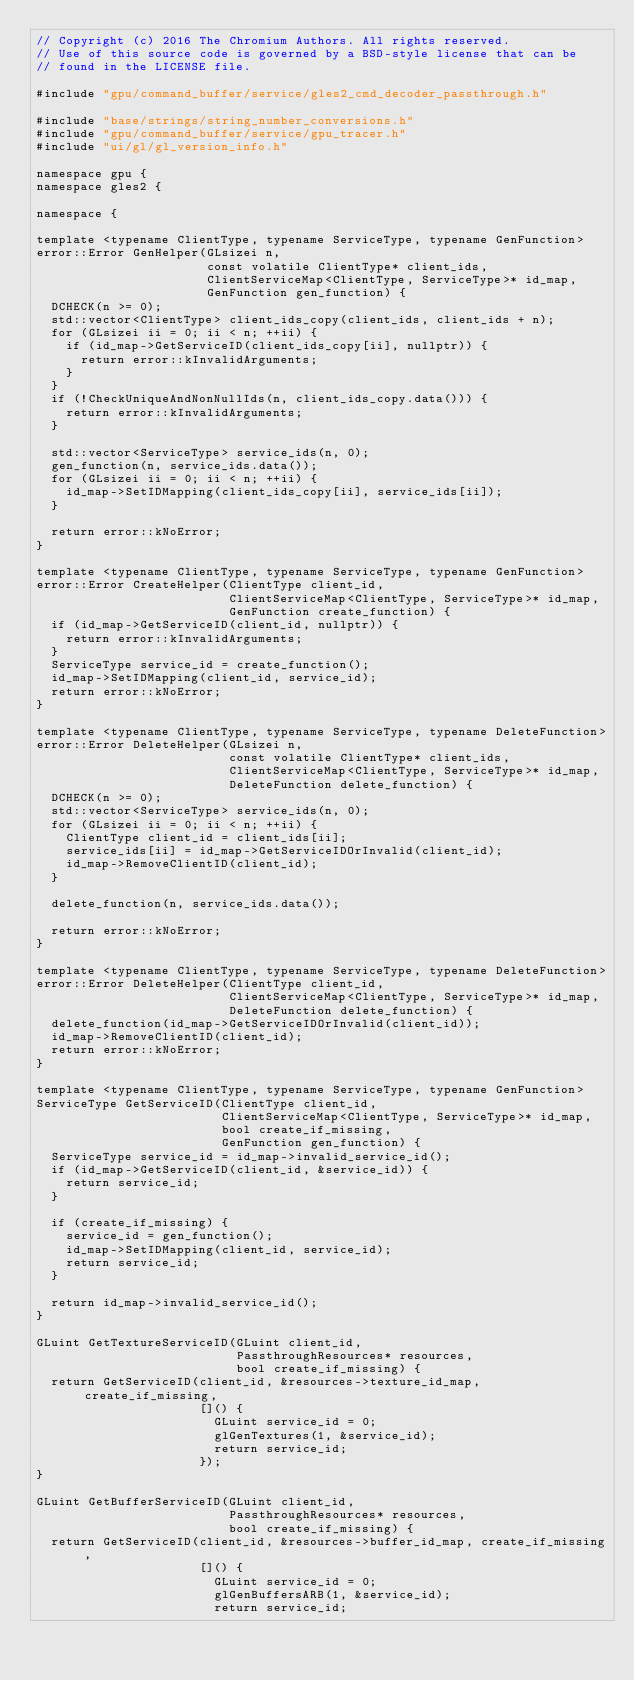<code> <loc_0><loc_0><loc_500><loc_500><_C++_>// Copyright (c) 2016 The Chromium Authors. All rights reserved.
// Use of this source code is governed by a BSD-style license that can be
// found in the LICENSE file.

#include "gpu/command_buffer/service/gles2_cmd_decoder_passthrough.h"

#include "base/strings/string_number_conversions.h"
#include "gpu/command_buffer/service/gpu_tracer.h"
#include "ui/gl/gl_version_info.h"

namespace gpu {
namespace gles2 {

namespace {

template <typename ClientType, typename ServiceType, typename GenFunction>
error::Error GenHelper(GLsizei n,
                       const volatile ClientType* client_ids,
                       ClientServiceMap<ClientType, ServiceType>* id_map,
                       GenFunction gen_function) {
  DCHECK(n >= 0);
  std::vector<ClientType> client_ids_copy(client_ids, client_ids + n);
  for (GLsizei ii = 0; ii < n; ++ii) {
    if (id_map->GetServiceID(client_ids_copy[ii], nullptr)) {
      return error::kInvalidArguments;
    }
  }
  if (!CheckUniqueAndNonNullIds(n, client_ids_copy.data())) {
    return error::kInvalidArguments;
  }

  std::vector<ServiceType> service_ids(n, 0);
  gen_function(n, service_ids.data());
  for (GLsizei ii = 0; ii < n; ++ii) {
    id_map->SetIDMapping(client_ids_copy[ii], service_ids[ii]);
  }

  return error::kNoError;
}

template <typename ClientType, typename ServiceType, typename GenFunction>
error::Error CreateHelper(ClientType client_id,
                          ClientServiceMap<ClientType, ServiceType>* id_map,
                          GenFunction create_function) {
  if (id_map->GetServiceID(client_id, nullptr)) {
    return error::kInvalidArguments;
  }
  ServiceType service_id = create_function();
  id_map->SetIDMapping(client_id, service_id);
  return error::kNoError;
}

template <typename ClientType, typename ServiceType, typename DeleteFunction>
error::Error DeleteHelper(GLsizei n,
                          const volatile ClientType* client_ids,
                          ClientServiceMap<ClientType, ServiceType>* id_map,
                          DeleteFunction delete_function) {
  DCHECK(n >= 0);
  std::vector<ServiceType> service_ids(n, 0);
  for (GLsizei ii = 0; ii < n; ++ii) {
    ClientType client_id = client_ids[ii];
    service_ids[ii] = id_map->GetServiceIDOrInvalid(client_id);
    id_map->RemoveClientID(client_id);
  }

  delete_function(n, service_ids.data());

  return error::kNoError;
}

template <typename ClientType, typename ServiceType, typename DeleteFunction>
error::Error DeleteHelper(ClientType client_id,
                          ClientServiceMap<ClientType, ServiceType>* id_map,
                          DeleteFunction delete_function) {
  delete_function(id_map->GetServiceIDOrInvalid(client_id));
  id_map->RemoveClientID(client_id);
  return error::kNoError;
}

template <typename ClientType, typename ServiceType, typename GenFunction>
ServiceType GetServiceID(ClientType client_id,
                         ClientServiceMap<ClientType, ServiceType>* id_map,
                         bool create_if_missing,
                         GenFunction gen_function) {
  ServiceType service_id = id_map->invalid_service_id();
  if (id_map->GetServiceID(client_id, &service_id)) {
    return service_id;
  }

  if (create_if_missing) {
    service_id = gen_function();
    id_map->SetIDMapping(client_id, service_id);
    return service_id;
  }

  return id_map->invalid_service_id();
}

GLuint GetTextureServiceID(GLuint client_id,
                           PassthroughResources* resources,
                           bool create_if_missing) {
  return GetServiceID(client_id, &resources->texture_id_map, create_if_missing,
                      []() {
                        GLuint service_id = 0;
                        glGenTextures(1, &service_id);
                        return service_id;
                      });
}

GLuint GetBufferServiceID(GLuint client_id,
                          PassthroughResources* resources,
                          bool create_if_missing) {
  return GetServiceID(client_id, &resources->buffer_id_map, create_if_missing,
                      []() {
                        GLuint service_id = 0;
                        glGenBuffersARB(1, &service_id);
                        return service_id;</code> 